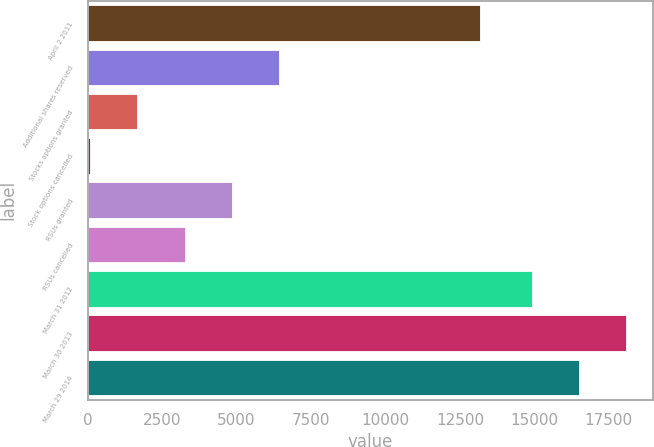Convert chart to OTSL. <chart><loc_0><loc_0><loc_500><loc_500><bar_chart><fcel>April 2 2011<fcel>Additional shares reserved<fcel>Stocks options granted<fcel>Stock options cancelled<fcel>RSUs granted<fcel>RSUs cancelled<fcel>March 31 2012<fcel>March 30 2013<fcel>March 29 2014<nl><fcel>13164<fcel>6438<fcel>1662<fcel>70<fcel>4846<fcel>3254<fcel>14908<fcel>18092<fcel>16500<nl></chart> 